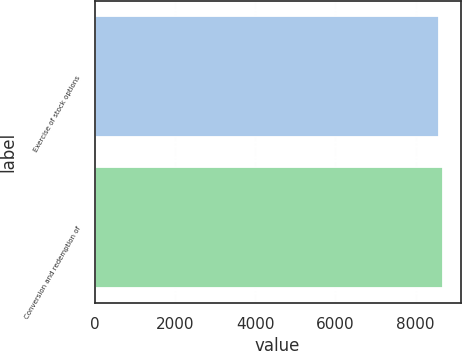<chart> <loc_0><loc_0><loc_500><loc_500><bar_chart><fcel>Exercise of stock options<fcel>Conversion and redemption of<nl><fcel>8586<fcel>8686<nl></chart> 